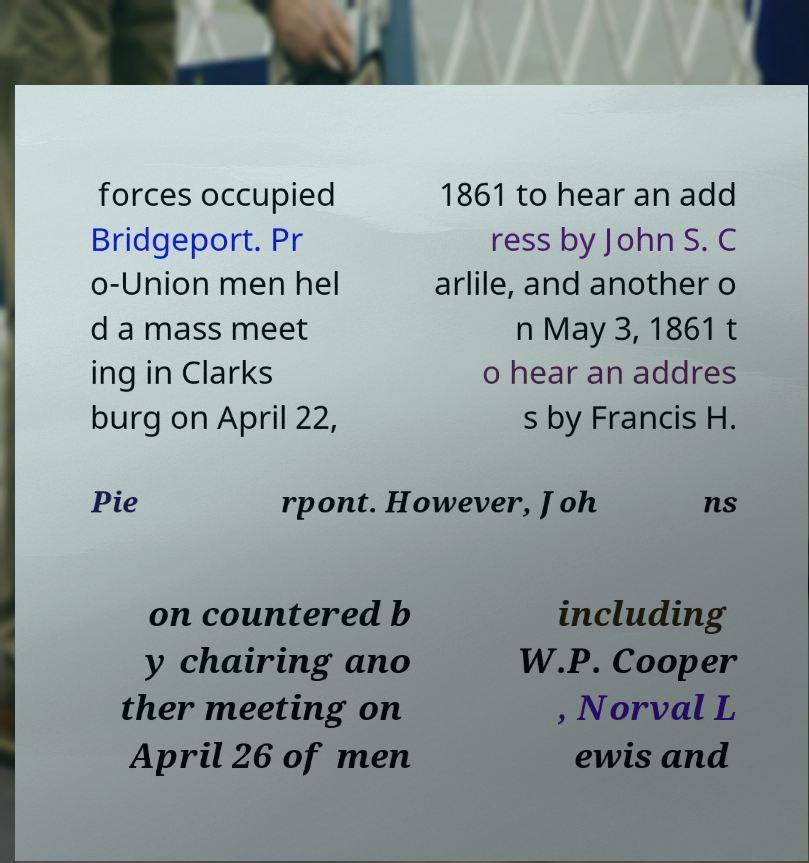Can you read and provide the text displayed in the image?This photo seems to have some interesting text. Can you extract and type it out for me? forces occupied Bridgeport. Pr o-Union men hel d a mass meet ing in Clarks burg on April 22, 1861 to hear an add ress by John S. C arlile, and another o n May 3, 1861 t o hear an addres s by Francis H. Pie rpont. However, Joh ns on countered b y chairing ano ther meeting on April 26 of men including W.P. Cooper , Norval L ewis and 